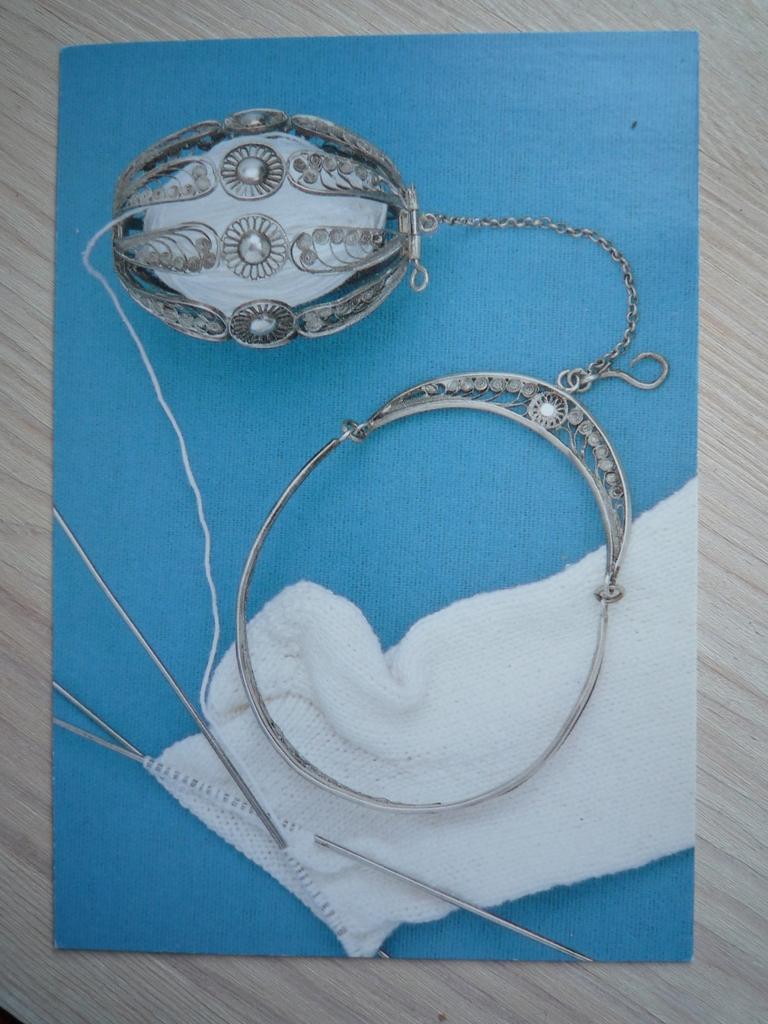Could you give a brief overview of what you see in this image? In this image a blue color paper is placed on a wooden surface. On this paper I can see a cloth, needles, thread and a metal object. 